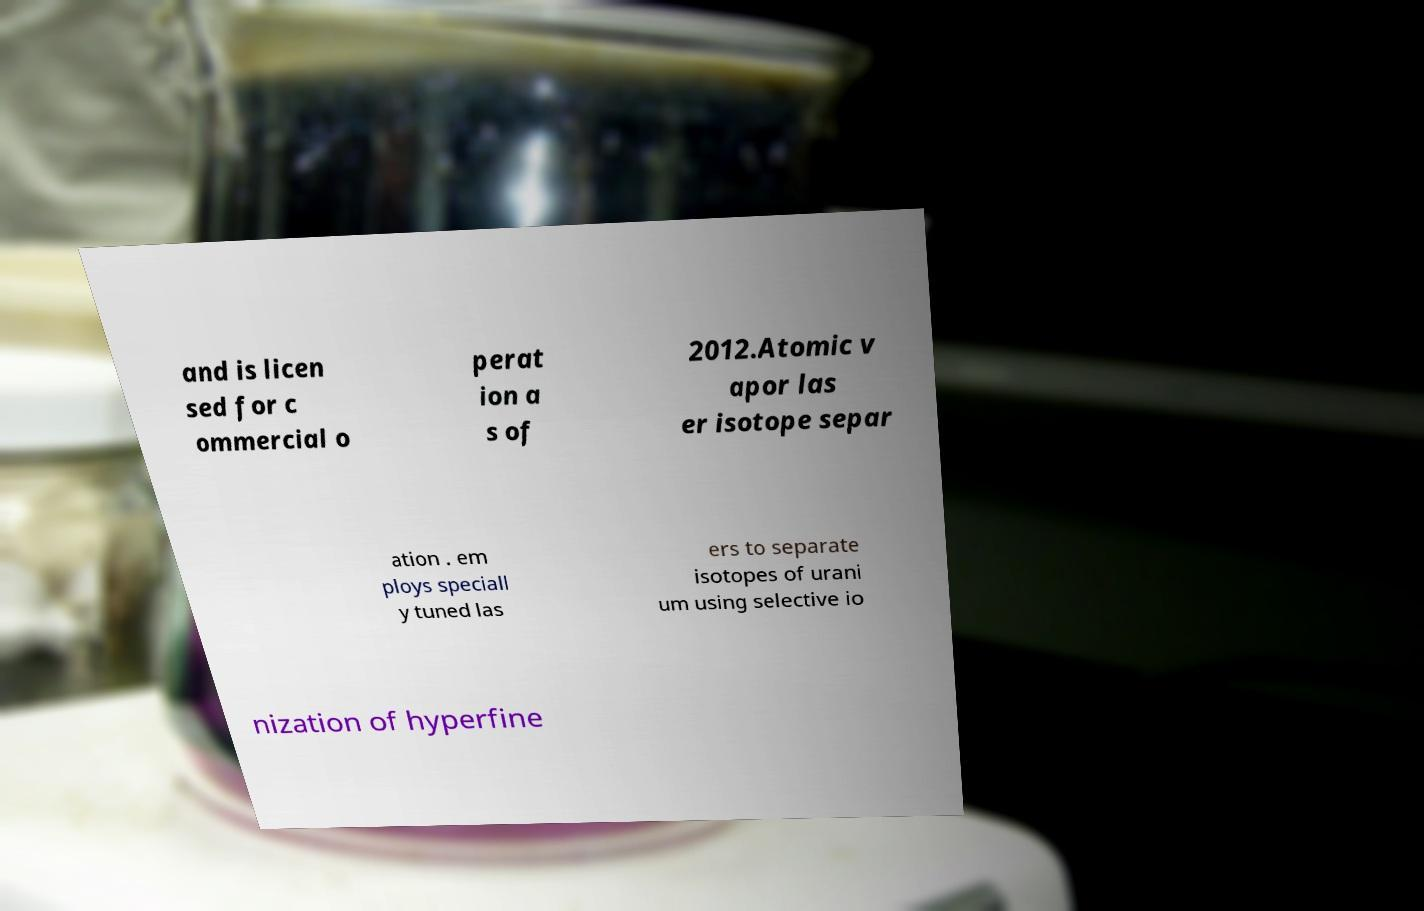Please read and relay the text visible in this image. What does it say? and is licen sed for c ommercial o perat ion a s of 2012.Atomic v apor las er isotope separ ation . em ploys speciall y tuned las ers to separate isotopes of urani um using selective io nization of hyperfine 